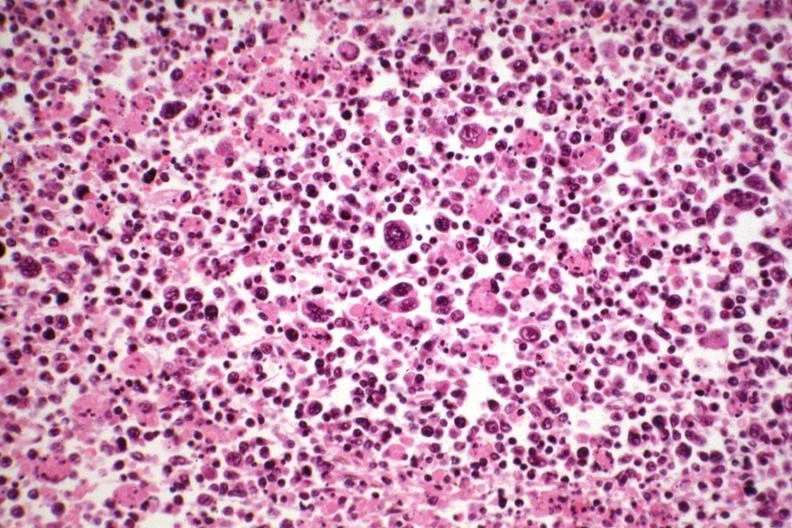s lymph node present?
Answer the question using a single word or phrase. Yes 